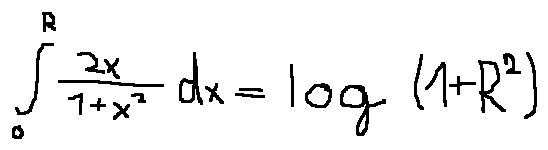<formula> <loc_0><loc_0><loc_500><loc_500>\int \lim i t s _ { 0 } ^ { R } \frac { 2 x } { 1 + x ^ { 2 } } d x = \log ( 1 + R ^ { 2 } )</formula> 